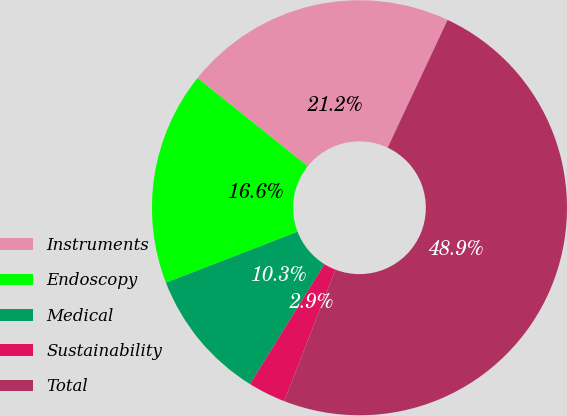Convert chart. <chart><loc_0><loc_0><loc_500><loc_500><pie_chart><fcel>Instruments<fcel>Endoscopy<fcel>Medical<fcel>Sustainability<fcel>Total<nl><fcel>21.23%<fcel>16.63%<fcel>10.27%<fcel>2.94%<fcel>48.92%<nl></chart> 